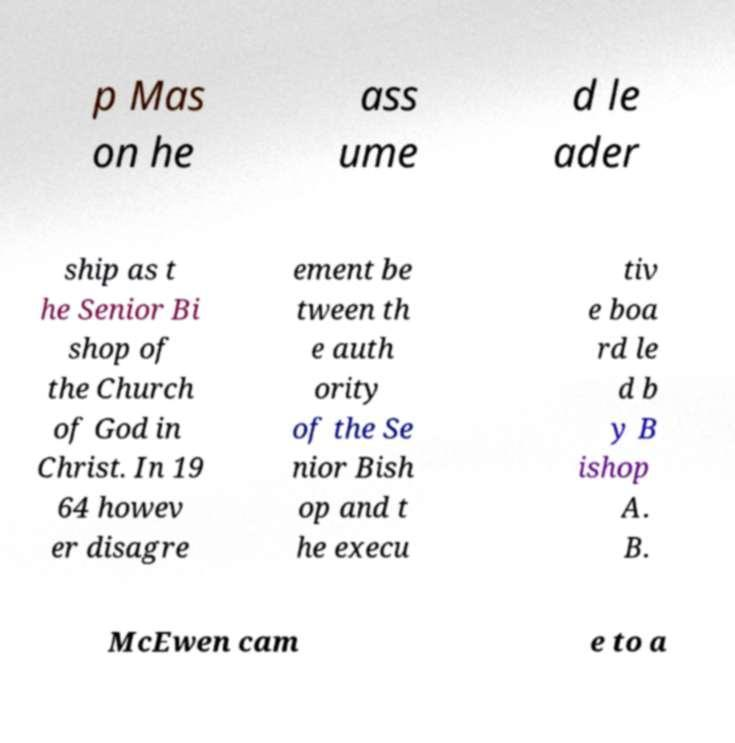For documentation purposes, I need the text within this image transcribed. Could you provide that? p Mas on he ass ume d le ader ship as t he Senior Bi shop of the Church of God in Christ. In 19 64 howev er disagre ement be tween th e auth ority of the Se nior Bish op and t he execu tiv e boa rd le d b y B ishop A. B. McEwen cam e to a 